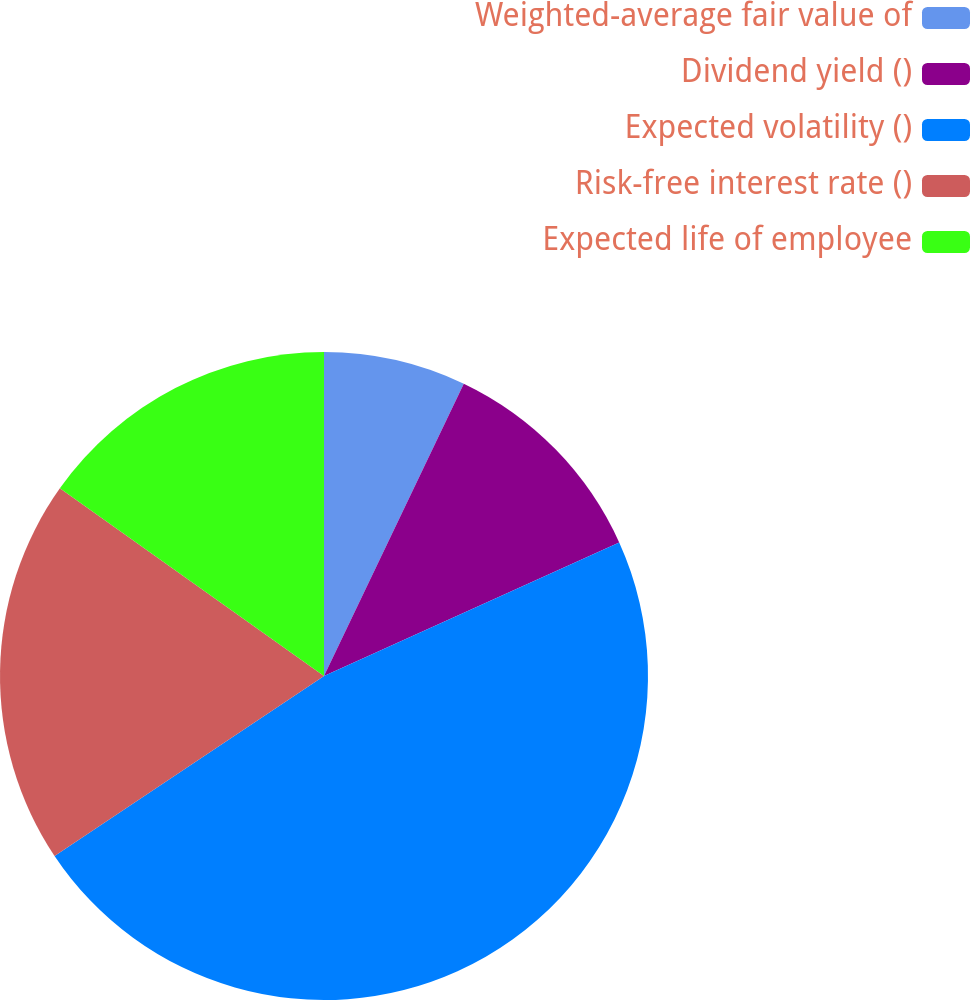Convert chart. <chart><loc_0><loc_0><loc_500><loc_500><pie_chart><fcel>Weighted-average fair value of<fcel>Dividend yield ()<fcel>Expected volatility ()<fcel>Risk-free interest rate ()<fcel>Expected life of employee<nl><fcel>7.1%<fcel>11.14%<fcel>47.39%<fcel>19.2%<fcel>15.17%<nl></chart> 